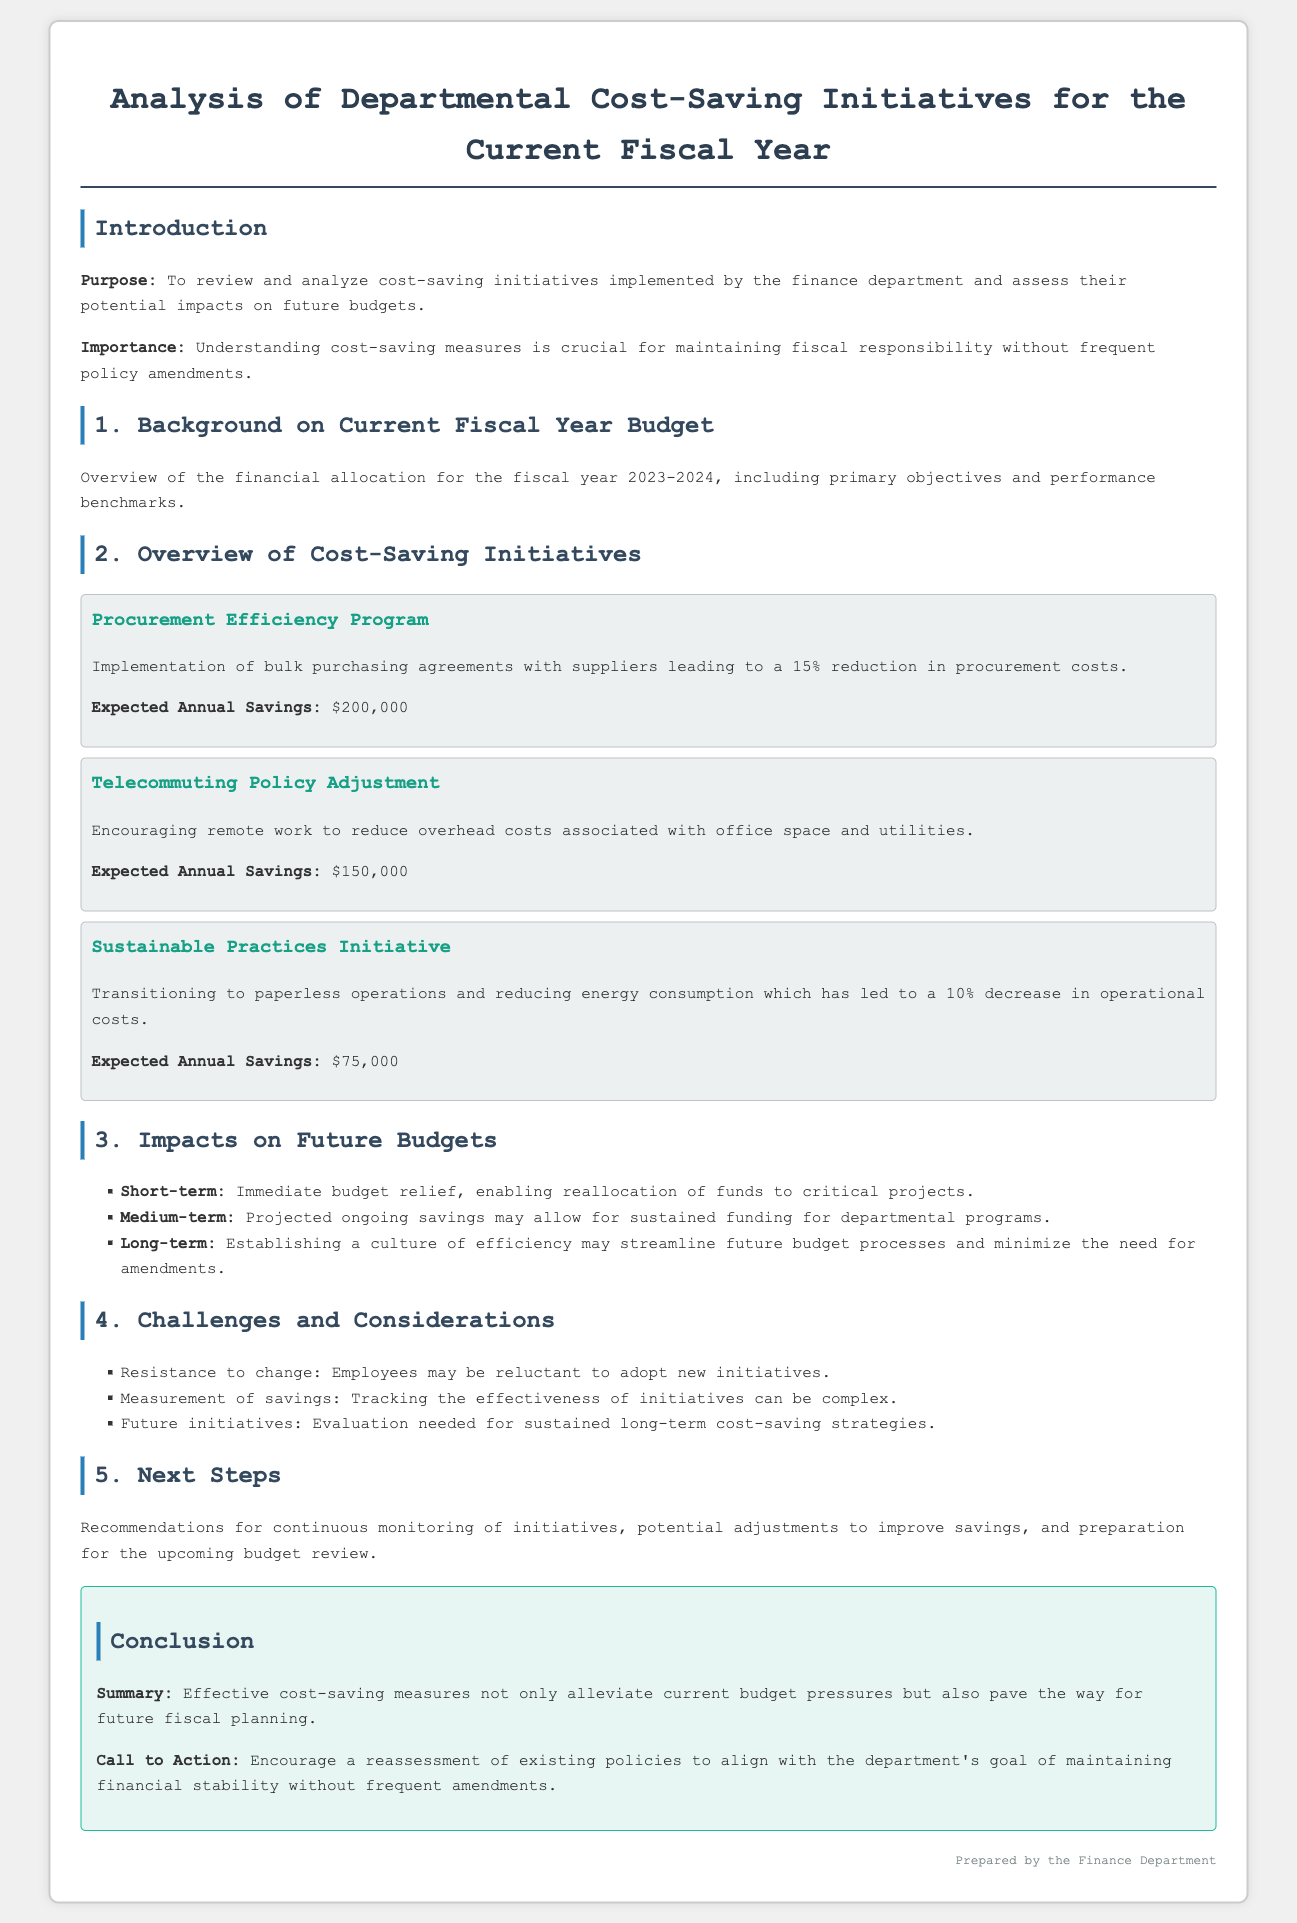What is the purpose of the analysis? The purpose of the analysis is to review and analyze cost-saving initiatives and assess their potential impacts on future budgets.
Answer: To review and analyze cost-saving initiatives and assess their potential impacts on future budgets What is the expected annual savings from the Procurement Efficiency Program? The expected annual savings from the Procurement Efficiency Program is explicitly mentioned in the document.
Answer: $200,000 What percentage reduction in operational costs is achieved through the Sustainable Practices Initiative? The document states a 10% decrease in operational costs due to the Sustainable Practices Initiative.
Answer: 10% What is the short-term impact of the cost-saving initiatives? The document outlines that the short-term impact is about immediate budget relief, enabling reallocation of funds.
Answer: Immediate budget relief What challenge is mentioned regarding employee response to new initiatives? One of the challenges noted in the document is resistance to change among employees.
Answer: Resistance to change What is the call to action highlighted in the conclusion? The call to action in the conclusion encourages reassessment of existing policies to maintain financial stability.
Answer: Reassessment of existing policies What is the expected annual savings from the Telecommuting Policy Adjustment? The expected annual savings from the Telecommuting Policy Adjustment is specified in the initiative section.
Answer: $150,000 What does the conclusion summarize about cost-saving measures? The conclusion summarizes that effective cost-saving measures alleviate budget pressures and facilitate future planning.
Answer: Alleviate current budget pressures What is the medium-term impact of the cost-saving initiatives? The document states that the medium-term impact relates to projected ongoing savings allowing sustained funding.
Answer: Sustained funding for departmental programs 